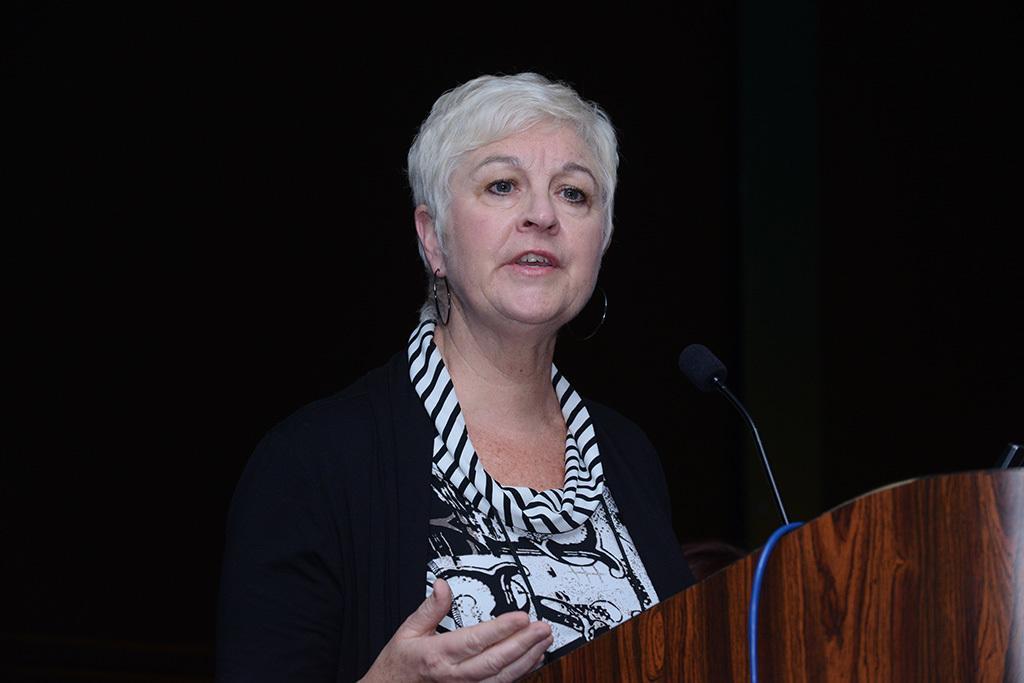Please provide a concise description of this image. In this image there is a person on the stage, in front of her there is a microphone and a cable on the podium. 